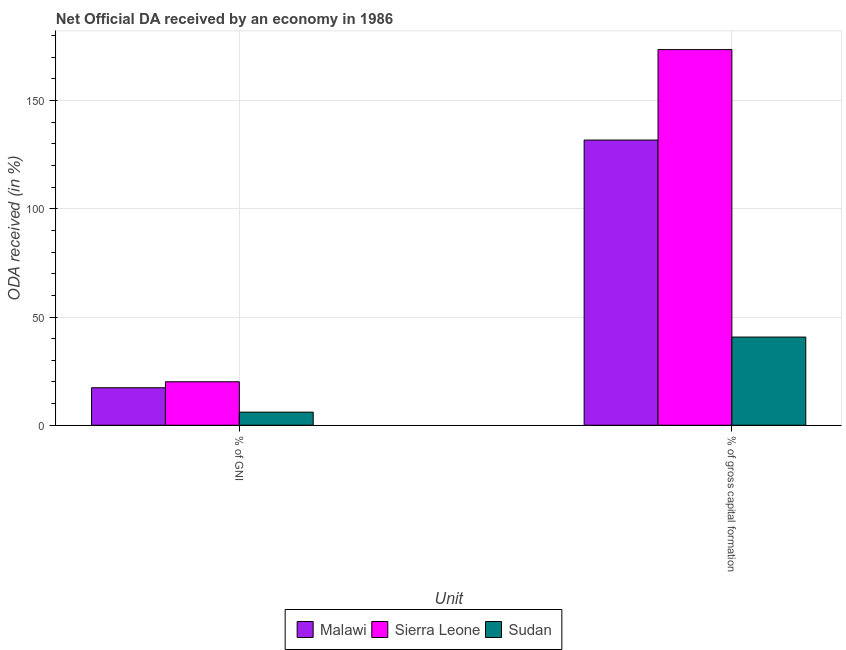How many groups of bars are there?
Your answer should be compact. 2. Are the number of bars per tick equal to the number of legend labels?
Provide a short and direct response. Yes. Are the number of bars on each tick of the X-axis equal?
Your answer should be compact. Yes. How many bars are there on the 1st tick from the right?
Your answer should be very brief. 3. What is the label of the 2nd group of bars from the left?
Keep it short and to the point. % of gross capital formation. What is the oda received as percentage of gni in Sudan?
Your answer should be compact. 6.05. Across all countries, what is the maximum oda received as percentage of gni?
Your answer should be compact. 20.08. Across all countries, what is the minimum oda received as percentage of gross capital formation?
Offer a very short reply. 40.74. In which country was the oda received as percentage of gni maximum?
Offer a very short reply. Sierra Leone. In which country was the oda received as percentage of gross capital formation minimum?
Give a very brief answer. Sudan. What is the total oda received as percentage of gross capital formation in the graph?
Give a very brief answer. 346.07. What is the difference between the oda received as percentage of gni in Sudan and that in Malawi?
Provide a short and direct response. -11.27. What is the difference between the oda received as percentage of gross capital formation in Sierra Leone and the oda received as percentage of gni in Sudan?
Ensure brevity in your answer.  167.51. What is the average oda received as percentage of gni per country?
Give a very brief answer. 14.48. What is the difference between the oda received as percentage of gni and oda received as percentage of gross capital formation in Malawi?
Offer a terse response. -114.45. What is the ratio of the oda received as percentage of gross capital formation in Malawi to that in Sudan?
Make the answer very short. 3.23. What does the 3rd bar from the left in % of GNI represents?
Provide a succinct answer. Sudan. What does the 1st bar from the right in % of GNI represents?
Your response must be concise. Sudan. How many bars are there?
Give a very brief answer. 6. Are all the bars in the graph horizontal?
Give a very brief answer. No. Does the graph contain grids?
Your answer should be very brief. Yes. How are the legend labels stacked?
Offer a terse response. Horizontal. What is the title of the graph?
Your answer should be very brief. Net Official DA received by an economy in 1986. Does "Venezuela" appear as one of the legend labels in the graph?
Your response must be concise. No. What is the label or title of the X-axis?
Offer a very short reply. Unit. What is the label or title of the Y-axis?
Offer a very short reply. ODA received (in %). What is the ODA received (in %) in Malawi in % of GNI?
Provide a succinct answer. 17.32. What is the ODA received (in %) of Sierra Leone in % of GNI?
Ensure brevity in your answer.  20.08. What is the ODA received (in %) in Sudan in % of GNI?
Offer a very short reply. 6.05. What is the ODA received (in %) in Malawi in % of gross capital formation?
Provide a short and direct response. 131.77. What is the ODA received (in %) in Sierra Leone in % of gross capital formation?
Offer a terse response. 173.56. What is the ODA received (in %) of Sudan in % of gross capital formation?
Your answer should be very brief. 40.74. Across all Unit, what is the maximum ODA received (in %) in Malawi?
Ensure brevity in your answer.  131.77. Across all Unit, what is the maximum ODA received (in %) in Sierra Leone?
Your answer should be compact. 173.56. Across all Unit, what is the maximum ODA received (in %) of Sudan?
Provide a short and direct response. 40.74. Across all Unit, what is the minimum ODA received (in %) in Malawi?
Offer a very short reply. 17.32. Across all Unit, what is the minimum ODA received (in %) of Sierra Leone?
Provide a succinct answer. 20.08. Across all Unit, what is the minimum ODA received (in %) of Sudan?
Offer a very short reply. 6.05. What is the total ODA received (in %) in Malawi in the graph?
Provide a short and direct response. 149.08. What is the total ODA received (in %) of Sierra Leone in the graph?
Offer a terse response. 193.64. What is the total ODA received (in %) in Sudan in the graph?
Give a very brief answer. 46.79. What is the difference between the ODA received (in %) of Malawi in % of GNI and that in % of gross capital formation?
Make the answer very short. -114.45. What is the difference between the ODA received (in %) of Sierra Leone in % of GNI and that in % of gross capital formation?
Make the answer very short. -153.48. What is the difference between the ODA received (in %) in Sudan in % of GNI and that in % of gross capital formation?
Your answer should be compact. -34.69. What is the difference between the ODA received (in %) of Malawi in % of GNI and the ODA received (in %) of Sierra Leone in % of gross capital formation?
Make the answer very short. -156.24. What is the difference between the ODA received (in %) in Malawi in % of GNI and the ODA received (in %) in Sudan in % of gross capital formation?
Keep it short and to the point. -23.42. What is the difference between the ODA received (in %) in Sierra Leone in % of GNI and the ODA received (in %) in Sudan in % of gross capital formation?
Ensure brevity in your answer.  -20.66. What is the average ODA received (in %) of Malawi per Unit?
Keep it short and to the point. 74.54. What is the average ODA received (in %) in Sierra Leone per Unit?
Offer a very short reply. 96.82. What is the average ODA received (in %) of Sudan per Unit?
Your answer should be very brief. 23.4. What is the difference between the ODA received (in %) of Malawi and ODA received (in %) of Sierra Leone in % of GNI?
Make the answer very short. -2.76. What is the difference between the ODA received (in %) of Malawi and ODA received (in %) of Sudan in % of GNI?
Your answer should be very brief. 11.27. What is the difference between the ODA received (in %) in Sierra Leone and ODA received (in %) in Sudan in % of GNI?
Your answer should be compact. 14.03. What is the difference between the ODA received (in %) in Malawi and ODA received (in %) in Sierra Leone in % of gross capital formation?
Offer a very short reply. -41.79. What is the difference between the ODA received (in %) in Malawi and ODA received (in %) in Sudan in % of gross capital formation?
Offer a very short reply. 91.02. What is the difference between the ODA received (in %) of Sierra Leone and ODA received (in %) of Sudan in % of gross capital formation?
Provide a short and direct response. 132.82. What is the ratio of the ODA received (in %) of Malawi in % of GNI to that in % of gross capital formation?
Provide a succinct answer. 0.13. What is the ratio of the ODA received (in %) in Sierra Leone in % of GNI to that in % of gross capital formation?
Offer a very short reply. 0.12. What is the ratio of the ODA received (in %) of Sudan in % of GNI to that in % of gross capital formation?
Keep it short and to the point. 0.15. What is the difference between the highest and the second highest ODA received (in %) in Malawi?
Your response must be concise. 114.45. What is the difference between the highest and the second highest ODA received (in %) of Sierra Leone?
Your answer should be very brief. 153.48. What is the difference between the highest and the second highest ODA received (in %) of Sudan?
Your answer should be very brief. 34.69. What is the difference between the highest and the lowest ODA received (in %) of Malawi?
Keep it short and to the point. 114.45. What is the difference between the highest and the lowest ODA received (in %) of Sierra Leone?
Offer a very short reply. 153.48. What is the difference between the highest and the lowest ODA received (in %) of Sudan?
Provide a succinct answer. 34.69. 